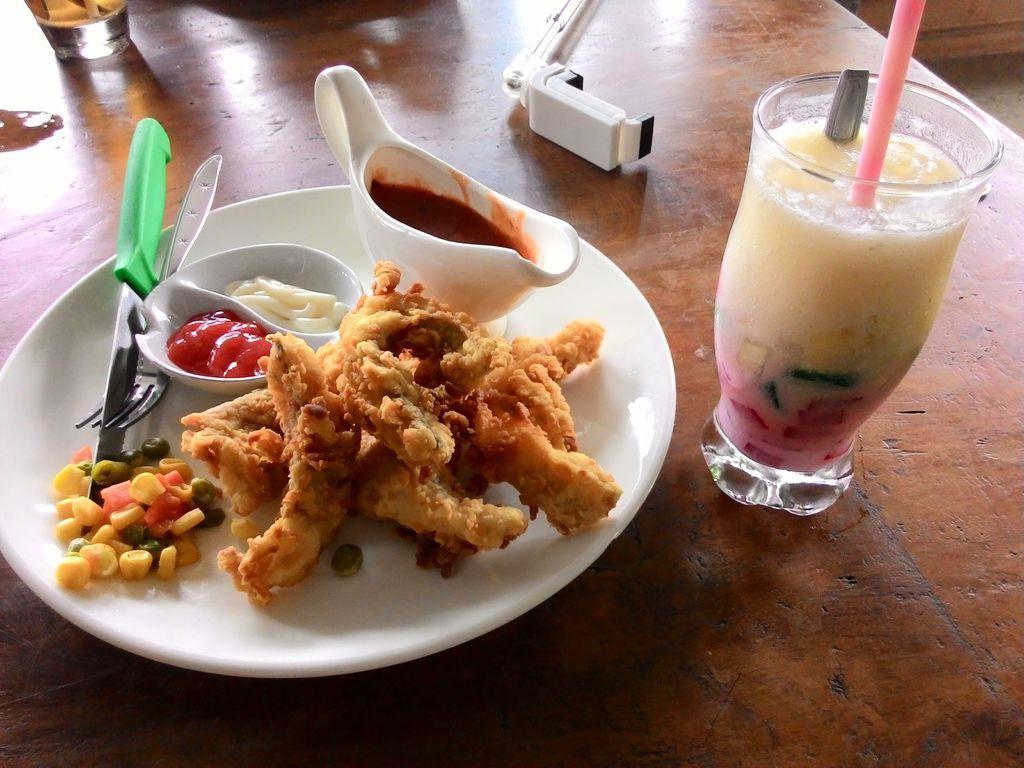Describe this image in one or two sentences. In the center of the image there is a table. On the table we can see glass, an object, a glass of juice with straw, spoon. A plate contain food item and knife, fork, ketchup are there. 